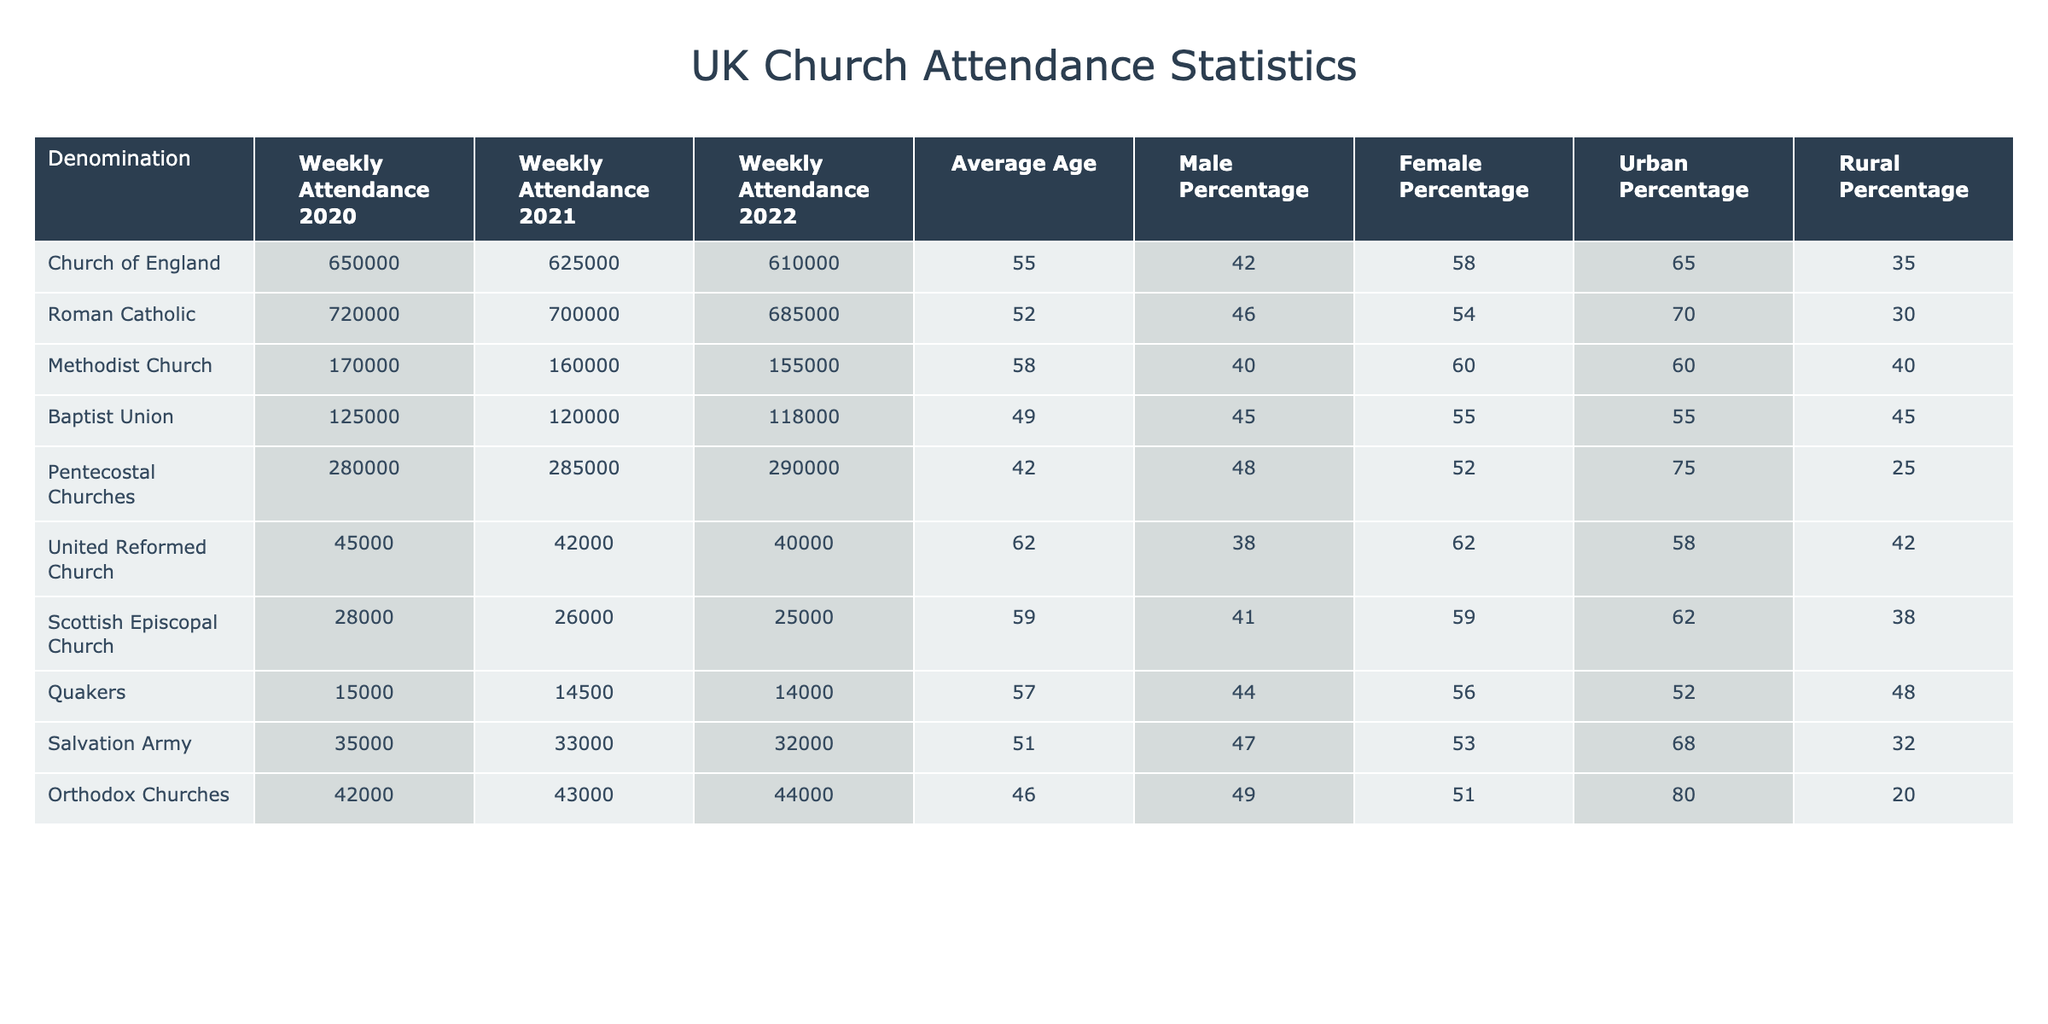What was the weekly attendance of the Church of England in 2022? The table shows the weekly attendance for each denomination across the years. For the Church of England, the weekly attendance in 2022 is listed as 610,000.
Answer: 610,000 Which denomination had the highest weekly attendance in 2021? By inspecting the weekly attendance values for 2021, the Roman Catholic Church has the highest attendance at 700,000.
Answer: Roman Catholic What is the average percentage of males across all the denominations listed? To find the average male percentage, sum the male percentages of each denomination (42 + 46 + 40 + 45 + 48 + 38 + 41 + 44 + 47 + 49 = 450) and divide by the number of denominations (10). This equals 450/10 = 45.
Answer: 45% Did the weekly attendance of the United Reformed Church decrease from 2020 to 2022? By comparing the weekly attendance values, we see that the attendance for the United Reformed Church dropped from 45,000 in 2020 to 40,000 in 2022. Therefore, it did decrease.
Answer: Yes Which denomination had the lowest average age of attendees? Looking at the average ages listed, the Pentecostal Churches have the lowest average age at 42 years.
Answer: Pentecostal Churches What is the difference in weekly attendance between the Roman Catholic and the Baptist Union in 2022? The weekly attendance for Roman Catholic in 2022 is 685,000 and for Baptist Union, it is 118,000. Subtracting the two: 685,000 - 118,000 = 567,000.
Answer: 567,000 True or False: The percentage of females in the Orthodox Churches is greater than 50%. The table shows that the female percentage for Orthodox Churches is 51%, which is indeed greater than 50%. Thus, the statement is true.
Answer: True What was the trend in weekly attendance for the Salvation Army from 2020 to 2022? By examining the figures, the weekly attendance declined from 35,000 in 2020 to 32,000 in 2022, indicating a downward trend.
Answer: Downward trend Which denomination has the highest percentage of attendance in urban areas? The Pentecostal Churches have the highest urban percentage at 75%, as indicated in the table.
Answer: Pentecostal Churches If we combine the weekly attendance of the Quakers and the Scottish Episcopal Church in 2022, what does that equal? The attendance for Quakers in 2022 is 14,000 and for Scottish Episcopal Church, it is 25,000. Combining these gives us 14,000 + 25,000 = 39,000.
Answer: 39,000 